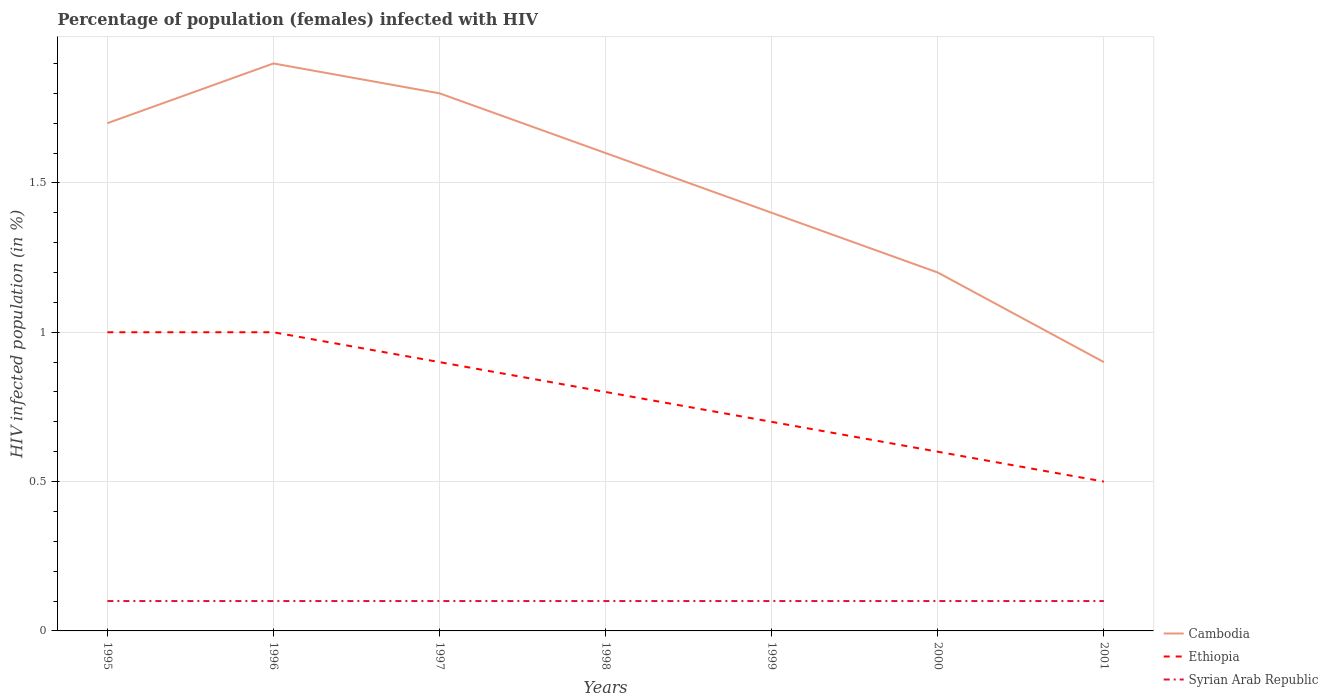How many different coloured lines are there?
Your response must be concise. 3. Is the number of lines equal to the number of legend labels?
Keep it short and to the point. Yes. In which year was the percentage of HIV infected female population in Syrian Arab Republic maximum?
Your answer should be compact. 1995. What is the total percentage of HIV infected female population in Ethiopia in the graph?
Your response must be concise. 0.2. How many years are there in the graph?
Ensure brevity in your answer.  7. Does the graph contain any zero values?
Keep it short and to the point. No. Where does the legend appear in the graph?
Provide a short and direct response. Bottom right. How many legend labels are there?
Make the answer very short. 3. What is the title of the graph?
Your answer should be compact. Percentage of population (females) infected with HIV. Does "Nepal" appear as one of the legend labels in the graph?
Ensure brevity in your answer.  No. What is the label or title of the X-axis?
Provide a short and direct response. Years. What is the label or title of the Y-axis?
Offer a very short reply. HIV infected population (in %). What is the HIV infected population (in %) of Syrian Arab Republic in 1995?
Ensure brevity in your answer.  0.1. What is the HIV infected population (in %) in Cambodia in 1996?
Ensure brevity in your answer.  1.9. What is the HIV infected population (in %) of Ethiopia in 1996?
Keep it short and to the point. 1. What is the HIV infected population (in %) of Cambodia in 1997?
Give a very brief answer. 1.8. What is the HIV infected population (in %) in Syrian Arab Republic in 1997?
Your answer should be very brief. 0.1. What is the HIV infected population (in %) of Syrian Arab Republic in 1998?
Your answer should be compact. 0.1. What is the HIV infected population (in %) in Ethiopia in 1999?
Give a very brief answer. 0.7. What is the HIV infected population (in %) in Syrian Arab Republic in 2000?
Provide a succinct answer. 0.1. What is the total HIV infected population (in %) of Cambodia in the graph?
Give a very brief answer. 10.5. What is the total HIV infected population (in %) of Syrian Arab Republic in the graph?
Make the answer very short. 0.7. What is the difference between the HIV infected population (in %) of Cambodia in 1995 and that in 1996?
Offer a terse response. -0.2. What is the difference between the HIV infected population (in %) in Ethiopia in 1995 and that in 1996?
Your answer should be very brief. 0. What is the difference between the HIV infected population (in %) in Syrian Arab Republic in 1995 and that in 1996?
Ensure brevity in your answer.  0. What is the difference between the HIV infected population (in %) in Cambodia in 1995 and that in 1997?
Provide a short and direct response. -0.1. What is the difference between the HIV infected population (in %) of Ethiopia in 1995 and that in 1997?
Give a very brief answer. 0.1. What is the difference between the HIV infected population (in %) of Cambodia in 1995 and that in 1998?
Provide a short and direct response. 0.1. What is the difference between the HIV infected population (in %) of Ethiopia in 1995 and that in 1998?
Keep it short and to the point. 0.2. What is the difference between the HIV infected population (in %) in Cambodia in 1995 and that in 2000?
Your response must be concise. 0.5. What is the difference between the HIV infected population (in %) of Syrian Arab Republic in 1995 and that in 2000?
Offer a terse response. 0. What is the difference between the HIV infected population (in %) of Ethiopia in 1995 and that in 2001?
Your answer should be compact. 0.5. What is the difference between the HIV infected population (in %) in Cambodia in 1996 and that in 1997?
Ensure brevity in your answer.  0.1. What is the difference between the HIV infected population (in %) of Ethiopia in 1996 and that in 1997?
Your answer should be compact. 0.1. What is the difference between the HIV infected population (in %) of Syrian Arab Republic in 1996 and that in 1997?
Your answer should be compact. 0. What is the difference between the HIV infected population (in %) of Syrian Arab Republic in 1996 and that in 1998?
Provide a succinct answer. 0. What is the difference between the HIV infected population (in %) of Cambodia in 1996 and that in 1999?
Keep it short and to the point. 0.5. What is the difference between the HIV infected population (in %) in Ethiopia in 1996 and that in 1999?
Offer a very short reply. 0.3. What is the difference between the HIV infected population (in %) in Syrian Arab Republic in 1996 and that in 1999?
Offer a very short reply. 0. What is the difference between the HIV infected population (in %) in Cambodia in 1996 and that in 2000?
Your response must be concise. 0.7. What is the difference between the HIV infected population (in %) in Ethiopia in 1996 and that in 2000?
Offer a terse response. 0.4. What is the difference between the HIV infected population (in %) in Syrian Arab Republic in 1996 and that in 2000?
Give a very brief answer. 0. What is the difference between the HIV infected population (in %) in Cambodia in 1996 and that in 2001?
Your response must be concise. 1. What is the difference between the HIV infected population (in %) of Ethiopia in 1996 and that in 2001?
Provide a succinct answer. 0.5. What is the difference between the HIV infected population (in %) in Syrian Arab Republic in 1997 and that in 1998?
Your answer should be compact. 0. What is the difference between the HIV infected population (in %) of Ethiopia in 1997 and that in 2000?
Keep it short and to the point. 0.3. What is the difference between the HIV infected population (in %) in Cambodia in 1997 and that in 2001?
Your answer should be compact. 0.9. What is the difference between the HIV infected population (in %) in Cambodia in 1998 and that in 1999?
Make the answer very short. 0.2. What is the difference between the HIV infected population (in %) in Syrian Arab Republic in 1998 and that in 2000?
Your response must be concise. 0. What is the difference between the HIV infected population (in %) in Ethiopia in 1998 and that in 2001?
Your answer should be compact. 0.3. What is the difference between the HIV infected population (in %) of Syrian Arab Republic in 1998 and that in 2001?
Offer a terse response. 0. What is the difference between the HIV infected population (in %) of Cambodia in 1999 and that in 2000?
Provide a short and direct response. 0.2. What is the difference between the HIV infected population (in %) in Cambodia in 1999 and that in 2001?
Your answer should be very brief. 0.5. What is the difference between the HIV infected population (in %) of Ethiopia in 1999 and that in 2001?
Offer a terse response. 0.2. What is the difference between the HIV infected population (in %) in Syrian Arab Republic in 1999 and that in 2001?
Offer a terse response. 0. What is the difference between the HIV infected population (in %) of Syrian Arab Republic in 2000 and that in 2001?
Offer a very short reply. 0. What is the difference between the HIV infected population (in %) in Cambodia in 1995 and the HIV infected population (in %) in Ethiopia in 1996?
Ensure brevity in your answer.  0.7. What is the difference between the HIV infected population (in %) of Cambodia in 1995 and the HIV infected population (in %) of Syrian Arab Republic in 1996?
Keep it short and to the point. 1.6. What is the difference between the HIV infected population (in %) in Ethiopia in 1995 and the HIV infected population (in %) in Syrian Arab Republic in 1996?
Your answer should be compact. 0.9. What is the difference between the HIV infected population (in %) in Cambodia in 1995 and the HIV infected population (in %) in Ethiopia in 1997?
Offer a terse response. 0.8. What is the difference between the HIV infected population (in %) in Cambodia in 1995 and the HIV infected population (in %) in Syrian Arab Republic in 1998?
Your answer should be compact. 1.6. What is the difference between the HIV infected population (in %) of Ethiopia in 1995 and the HIV infected population (in %) of Syrian Arab Republic in 1998?
Offer a terse response. 0.9. What is the difference between the HIV infected population (in %) in Cambodia in 1995 and the HIV infected population (in %) in Syrian Arab Republic in 1999?
Your response must be concise. 1.6. What is the difference between the HIV infected population (in %) of Cambodia in 1995 and the HIV infected population (in %) of Ethiopia in 2000?
Your response must be concise. 1.1. What is the difference between the HIV infected population (in %) in Ethiopia in 1995 and the HIV infected population (in %) in Syrian Arab Republic in 2000?
Your response must be concise. 0.9. What is the difference between the HIV infected population (in %) in Cambodia in 1995 and the HIV infected population (in %) in Syrian Arab Republic in 2001?
Give a very brief answer. 1.6. What is the difference between the HIV infected population (in %) in Ethiopia in 1995 and the HIV infected population (in %) in Syrian Arab Republic in 2001?
Offer a very short reply. 0.9. What is the difference between the HIV infected population (in %) of Cambodia in 1996 and the HIV infected population (in %) of Ethiopia in 1997?
Keep it short and to the point. 1. What is the difference between the HIV infected population (in %) of Cambodia in 1996 and the HIV infected population (in %) of Syrian Arab Republic in 1997?
Ensure brevity in your answer.  1.8. What is the difference between the HIV infected population (in %) of Ethiopia in 1996 and the HIV infected population (in %) of Syrian Arab Republic in 1997?
Your answer should be compact. 0.9. What is the difference between the HIV infected population (in %) of Cambodia in 1996 and the HIV infected population (in %) of Ethiopia in 1998?
Your answer should be very brief. 1.1. What is the difference between the HIV infected population (in %) in Cambodia in 1996 and the HIV infected population (in %) in Syrian Arab Republic in 1998?
Offer a very short reply. 1.8. What is the difference between the HIV infected population (in %) of Ethiopia in 1996 and the HIV infected population (in %) of Syrian Arab Republic in 1998?
Keep it short and to the point. 0.9. What is the difference between the HIV infected population (in %) of Ethiopia in 1996 and the HIV infected population (in %) of Syrian Arab Republic in 1999?
Give a very brief answer. 0.9. What is the difference between the HIV infected population (in %) of Cambodia in 1996 and the HIV infected population (in %) of Syrian Arab Republic in 2000?
Make the answer very short. 1.8. What is the difference between the HIV infected population (in %) of Ethiopia in 1996 and the HIV infected population (in %) of Syrian Arab Republic in 2001?
Offer a terse response. 0.9. What is the difference between the HIV infected population (in %) in Cambodia in 1997 and the HIV infected population (in %) in Ethiopia in 1998?
Give a very brief answer. 1. What is the difference between the HIV infected population (in %) in Cambodia in 1997 and the HIV infected population (in %) in Syrian Arab Republic in 1998?
Your response must be concise. 1.7. What is the difference between the HIV infected population (in %) in Ethiopia in 1997 and the HIV infected population (in %) in Syrian Arab Republic in 1998?
Ensure brevity in your answer.  0.8. What is the difference between the HIV infected population (in %) in Cambodia in 1997 and the HIV infected population (in %) in Syrian Arab Republic in 1999?
Your response must be concise. 1.7. What is the difference between the HIV infected population (in %) of Cambodia in 1997 and the HIV infected population (in %) of Syrian Arab Republic in 2000?
Keep it short and to the point. 1.7. What is the difference between the HIV infected population (in %) of Ethiopia in 1997 and the HIV infected population (in %) of Syrian Arab Republic in 2001?
Your answer should be very brief. 0.8. What is the difference between the HIV infected population (in %) of Cambodia in 1998 and the HIV infected population (in %) of Ethiopia in 1999?
Ensure brevity in your answer.  0.9. What is the difference between the HIV infected population (in %) of Cambodia in 1998 and the HIV infected population (in %) of Syrian Arab Republic in 1999?
Your answer should be compact. 1.5. What is the difference between the HIV infected population (in %) of Cambodia in 1998 and the HIV infected population (in %) of Ethiopia in 2000?
Keep it short and to the point. 1. What is the difference between the HIV infected population (in %) in Cambodia in 1998 and the HIV infected population (in %) in Syrian Arab Republic in 2000?
Offer a very short reply. 1.5. What is the difference between the HIV infected population (in %) in Cambodia in 1998 and the HIV infected population (in %) in Ethiopia in 2001?
Give a very brief answer. 1.1. What is the difference between the HIV infected population (in %) of Cambodia in 1998 and the HIV infected population (in %) of Syrian Arab Republic in 2001?
Provide a succinct answer. 1.5. What is the difference between the HIV infected population (in %) of Ethiopia in 1998 and the HIV infected population (in %) of Syrian Arab Republic in 2001?
Your answer should be compact. 0.7. What is the difference between the HIV infected population (in %) of Cambodia in 1999 and the HIV infected population (in %) of Syrian Arab Republic in 2000?
Offer a very short reply. 1.3. What is the difference between the HIV infected population (in %) of Ethiopia in 1999 and the HIV infected population (in %) of Syrian Arab Republic in 2000?
Offer a very short reply. 0.6. What is the difference between the HIV infected population (in %) in Cambodia in 1999 and the HIV infected population (in %) in Ethiopia in 2001?
Your answer should be very brief. 0.9. What is the difference between the HIV infected population (in %) of Ethiopia in 2000 and the HIV infected population (in %) of Syrian Arab Republic in 2001?
Your answer should be compact. 0.5. What is the average HIV infected population (in %) in Cambodia per year?
Your answer should be very brief. 1.5. What is the average HIV infected population (in %) of Ethiopia per year?
Make the answer very short. 0.79. In the year 1995, what is the difference between the HIV infected population (in %) of Ethiopia and HIV infected population (in %) of Syrian Arab Republic?
Your answer should be very brief. 0.9. In the year 1996, what is the difference between the HIV infected population (in %) in Cambodia and HIV infected population (in %) in Syrian Arab Republic?
Ensure brevity in your answer.  1.8. In the year 1996, what is the difference between the HIV infected population (in %) in Ethiopia and HIV infected population (in %) in Syrian Arab Republic?
Offer a very short reply. 0.9. In the year 1997, what is the difference between the HIV infected population (in %) of Ethiopia and HIV infected population (in %) of Syrian Arab Republic?
Your response must be concise. 0.8. In the year 1998, what is the difference between the HIV infected population (in %) of Cambodia and HIV infected population (in %) of Ethiopia?
Make the answer very short. 0.8. In the year 1999, what is the difference between the HIV infected population (in %) in Cambodia and HIV infected population (in %) in Syrian Arab Republic?
Offer a terse response. 1.3. In the year 1999, what is the difference between the HIV infected population (in %) in Ethiopia and HIV infected population (in %) in Syrian Arab Republic?
Ensure brevity in your answer.  0.6. In the year 2000, what is the difference between the HIV infected population (in %) of Cambodia and HIV infected population (in %) of Syrian Arab Republic?
Provide a succinct answer. 1.1. In the year 2000, what is the difference between the HIV infected population (in %) of Ethiopia and HIV infected population (in %) of Syrian Arab Republic?
Provide a succinct answer. 0.5. In the year 2001, what is the difference between the HIV infected population (in %) of Cambodia and HIV infected population (in %) of Ethiopia?
Make the answer very short. 0.4. What is the ratio of the HIV infected population (in %) of Cambodia in 1995 to that in 1996?
Offer a terse response. 0.89. What is the ratio of the HIV infected population (in %) of Ethiopia in 1995 to that in 1996?
Give a very brief answer. 1. What is the ratio of the HIV infected population (in %) in Cambodia in 1995 to that in 1997?
Give a very brief answer. 0.94. What is the ratio of the HIV infected population (in %) of Ethiopia in 1995 to that in 1998?
Ensure brevity in your answer.  1.25. What is the ratio of the HIV infected population (in %) of Syrian Arab Republic in 1995 to that in 1998?
Provide a short and direct response. 1. What is the ratio of the HIV infected population (in %) of Cambodia in 1995 to that in 1999?
Your answer should be very brief. 1.21. What is the ratio of the HIV infected population (in %) of Ethiopia in 1995 to that in 1999?
Your answer should be compact. 1.43. What is the ratio of the HIV infected population (in %) of Syrian Arab Republic in 1995 to that in 1999?
Make the answer very short. 1. What is the ratio of the HIV infected population (in %) in Cambodia in 1995 to that in 2000?
Your response must be concise. 1.42. What is the ratio of the HIV infected population (in %) in Ethiopia in 1995 to that in 2000?
Ensure brevity in your answer.  1.67. What is the ratio of the HIV infected population (in %) in Syrian Arab Republic in 1995 to that in 2000?
Provide a succinct answer. 1. What is the ratio of the HIV infected population (in %) of Cambodia in 1995 to that in 2001?
Offer a terse response. 1.89. What is the ratio of the HIV infected population (in %) in Syrian Arab Republic in 1995 to that in 2001?
Provide a succinct answer. 1. What is the ratio of the HIV infected population (in %) in Cambodia in 1996 to that in 1997?
Keep it short and to the point. 1.06. What is the ratio of the HIV infected population (in %) of Ethiopia in 1996 to that in 1997?
Your answer should be compact. 1.11. What is the ratio of the HIV infected population (in %) of Cambodia in 1996 to that in 1998?
Provide a short and direct response. 1.19. What is the ratio of the HIV infected population (in %) in Cambodia in 1996 to that in 1999?
Provide a short and direct response. 1.36. What is the ratio of the HIV infected population (in %) of Ethiopia in 1996 to that in 1999?
Your response must be concise. 1.43. What is the ratio of the HIV infected population (in %) of Cambodia in 1996 to that in 2000?
Your answer should be compact. 1.58. What is the ratio of the HIV infected population (in %) in Ethiopia in 1996 to that in 2000?
Your response must be concise. 1.67. What is the ratio of the HIV infected population (in %) of Cambodia in 1996 to that in 2001?
Ensure brevity in your answer.  2.11. What is the ratio of the HIV infected population (in %) of Ethiopia in 1996 to that in 2001?
Make the answer very short. 2. What is the ratio of the HIV infected population (in %) of Syrian Arab Republic in 1996 to that in 2001?
Make the answer very short. 1. What is the ratio of the HIV infected population (in %) of Syrian Arab Republic in 1997 to that in 1998?
Your answer should be compact. 1. What is the ratio of the HIV infected population (in %) of Syrian Arab Republic in 1997 to that in 1999?
Keep it short and to the point. 1. What is the ratio of the HIV infected population (in %) of Cambodia in 1997 to that in 2000?
Ensure brevity in your answer.  1.5. What is the ratio of the HIV infected population (in %) in Syrian Arab Republic in 1997 to that in 2000?
Your response must be concise. 1. What is the ratio of the HIV infected population (in %) of Ethiopia in 1997 to that in 2001?
Your answer should be very brief. 1.8. What is the ratio of the HIV infected population (in %) in Syrian Arab Republic in 1997 to that in 2001?
Ensure brevity in your answer.  1. What is the ratio of the HIV infected population (in %) of Cambodia in 1998 to that in 2000?
Ensure brevity in your answer.  1.33. What is the ratio of the HIV infected population (in %) of Syrian Arab Republic in 1998 to that in 2000?
Your response must be concise. 1. What is the ratio of the HIV infected population (in %) in Cambodia in 1998 to that in 2001?
Provide a short and direct response. 1.78. What is the ratio of the HIV infected population (in %) of Syrian Arab Republic in 1998 to that in 2001?
Give a very brief answer. 1. What is the ratio of the HIV infected population (in %) of Cambodia in 1999 to that in 2000?
Ensure brevity in your answer.  1.17. What is the ratio of the HIV infected population (in %) of Syrian Arab Republic in 1999 to that in 2000?
Your answer should be very brief. 1. What is the ratio of the HIV infected population (in %) in Cambodia in 1999 to that in 2001?
Make the answer very short. 1.56. What is the ratio of the HIV infected population (in %) of Ethiopia in 1999 to that in 2001?
Provide a short and direct response. 1.4. What is the ratio of the HIV infected population (in %) in Syrian Arab Republic in 1999 to that in 2001?
Provide a succinct answer. 1. What is the difference between the highest and the second highest HIV infected population (in %) in Cambodia?
Keep it short and to the point. 0.1. What is the difference between the highest and the second highest HIV infected population (in %) of Syrian Arab Republic?
Your response must be concise. 0. What is the difference between the highest and the lowest HIV infected population (in %) of Ethiopia?
Offer a terse response. 0.5. 